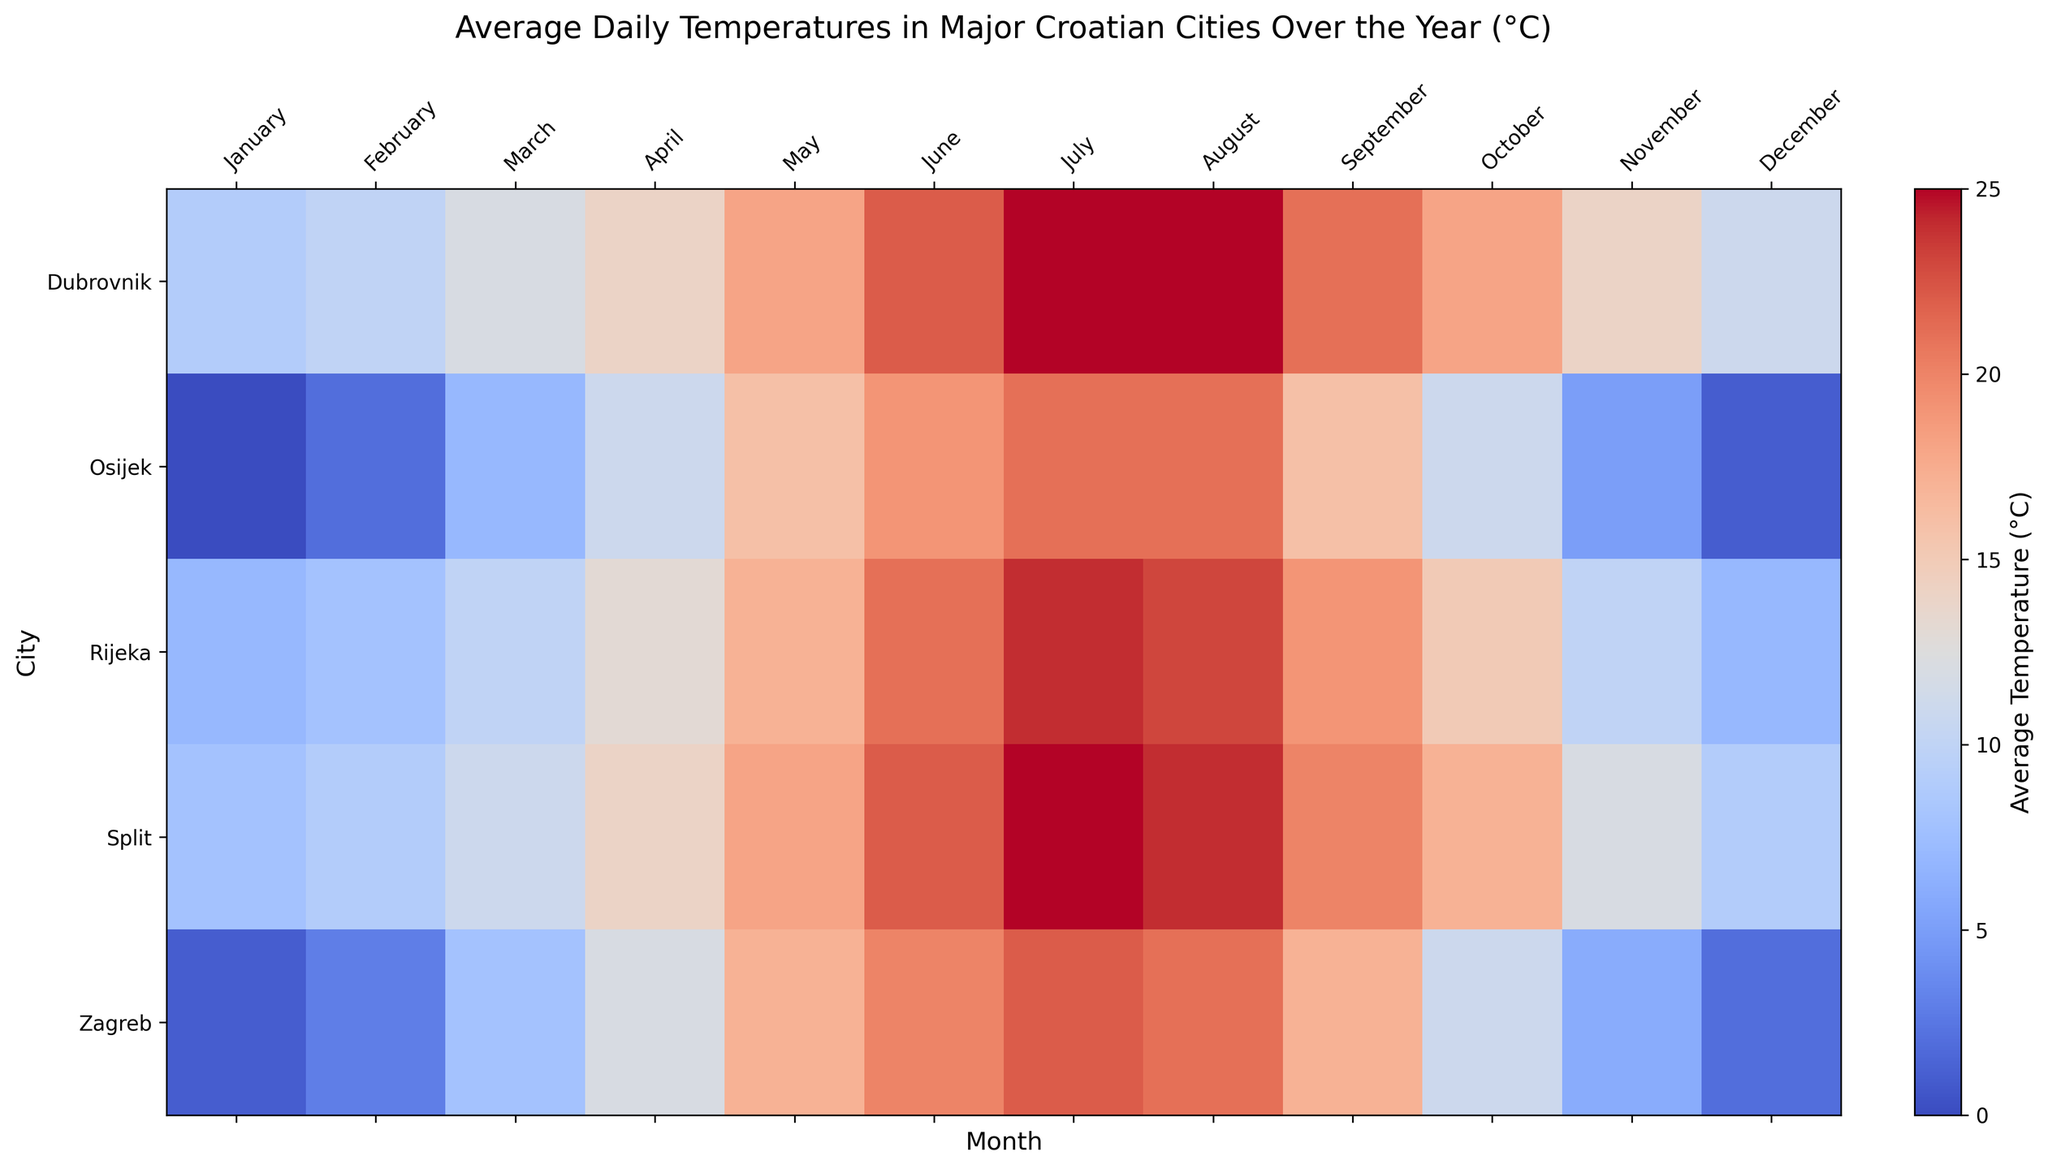What is the average temperature in July for all the cities? First, locate the temperatures for July in Zagreb, Split, Dubrovnik, Rijeka, and Osijek: 22, 25, 25, 24, and 21 respectively. Add these values: 22 + 25 + 25 + 24 + 21 = 117. Divide the sum by the number of cities (5): 117 / 5 = 23.4
Answer: 23.4 Which city has the highest average temperature in February? Identify the temperatures for February in Zagreb (3), Split (9), Dubrovnik (10), Rijeka (8), and Osijek (2). Dubrovnik has the highest value.
Answer: Dubrovnik In which month is there the greatest temperature difference between Zagreb and Dubrovnik? Compare the temperatures for each month between Zagreb and Dubrovnik. The differences are: January (8), February (7), March (4), April (2), May (1), June (2), July (3), August (4), September (4), October (7), November (8), December (9). The greatest difference is in December (9).
Answer: December Which city has the coldest average temperature across the entire year? Calculate the average temperature for each city over all the months. Sum of temperatures: Zagreb (3+1+8+12+17+20+22+21+17+11+6+2 = 140), Split (8+9+11+14+18+22+25+24+20+17+12+9 = 189), Dubrovnik (9+10+12+14+18+22+25+25+21+18+14+11 = 199), Rijeka (7+8+10+13+17+21+24+23+19+15+10+7 = 174), Osijek (0+2+7+11+16+19+21+21+16+11+5+1 = 130). Divide by 12: Zagreb (140/12 ≈ 11.67), Split (189/12 ≈ 15.75), Dubrovnik (199/12 ≈ 16.58), Rijeka (174/12 ≈ 14.5), Osijek (130/12 ≈ 10.83). Osijek has the lowest average temperature.
Answer: Osijek What is the temperature range in Split during the year? Find the highest and lowest temperatures for Split: highest (25°C in July), lowest (8°C in January). Calculate the difference: 25 - 8 = 17
Answer: 17 How does Osijek's temperature in April compare to Split's temperature in the same month? Compare the temperatures: Osijek in April (11°C), Split in April (14°C). Split is warmer by 3°C.
Answer: Split is 3°C warmer In which month do Rijeka and Split have the same temperature? Identify the temperatures for each month. Rijeka and Split both have 8°C in February and 17°C in October.
Answer: February and October Which city experiences the highest average temperature in any month, and what is that temperature? Look for the highest temperatures: Zagreb (22 in July), Split (25 in July), Dubrovnik (25 in July and August), Rijeka (24 in July), Osijek (21 in July and August). Dubrovnik has the highest at 25°C, also matched by Split in July.
Answer: Dubrovnik and Split, 25°C In November, which city shows the highest temperature? Note the temperatures for November: Zagreb (6), Split (12), Dubrovnik (14), Rijeka (10), Osijek (5). Dubrovnik has the highest value.
Answer: Dubrovnik 